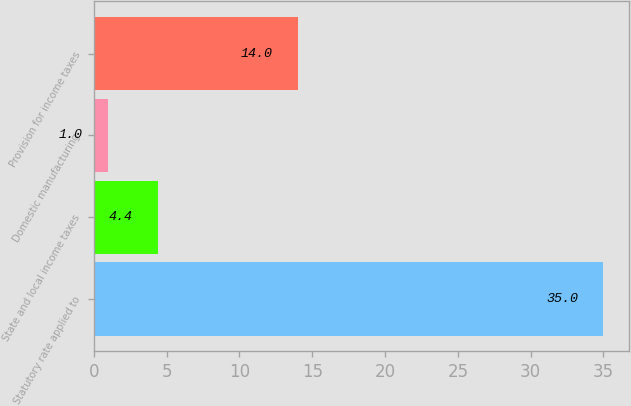Convert chart to OTSL. <chart><loc_0><loc_0><loc_500><loc_500><bar_chart><fcel>Statutory rate applied to<fcel>State and local income taxes<fcel>Domestic manufacturing<fcel>Provision for income taxes<nl><fcel>35<fcel>4.4<fcel>1<fcel>14<nl></chart> 